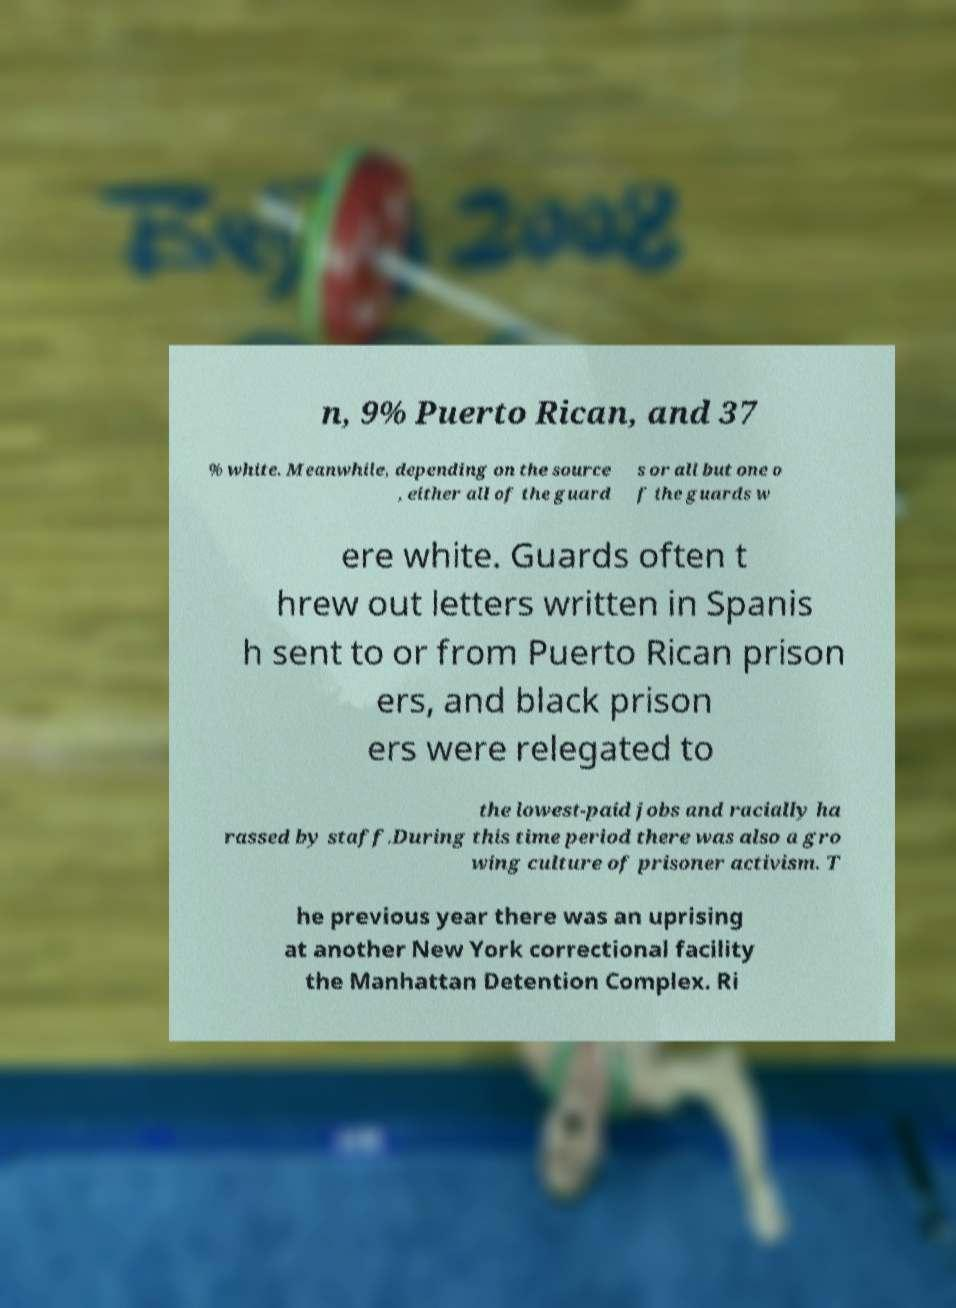There's text embedded in this image that I need extracted. Can you transcribe it verbatim? n, 9% Puerto Rican, and 37 % white. Meanwhile, depending on the source , either all of the guard s or all but one o f the guards w ere white. Guards often t hrew out letters written in Spanis h sent to or from Puerto Rican prison ers, and black prison ers were relegated to the lowest-paid jobs and racially ha rassed by staff.During this time period there was also a gro wing culture of prisoner activism. T he previous year there was an uprising at another New York correctional facility the Manhattan Detention Complex. Ri 